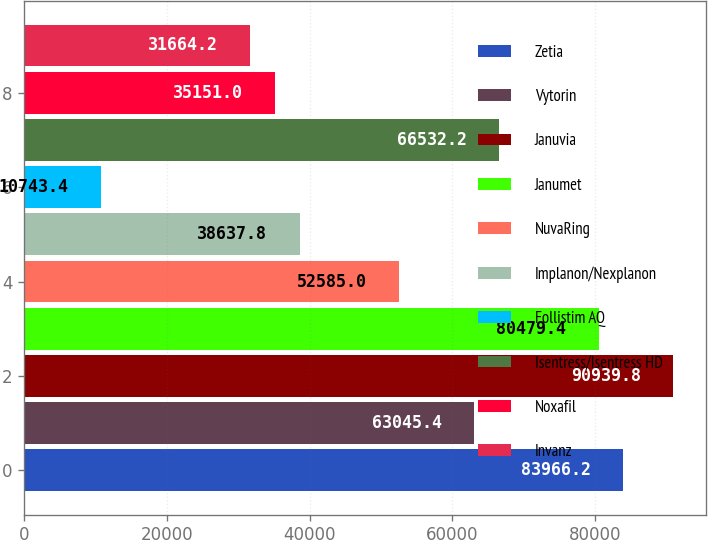Convert chart to OTSL. <chart><loc_0><loc_0><loc_500><loc_500><bar_chart><fcel>Zetia<fcel>Vytorin<fcel>Januvia<fcel>Janumet<fcel>NuvaRing<fcel>Implanon/Nexplanon<fcel>Follistim AQ<fcel>Isentress/Isentress HD<fcel>Noxafil<fcel>Invanz<nl><fcel>83966.2<fcel>63045.4<fcel>90939.8<fcel>80479.4<fcel>52585<fcel>38637.8<fcel>10743.4<fcel>66532.2<fcel>35151<fcel>31664.2<nl></chart> 